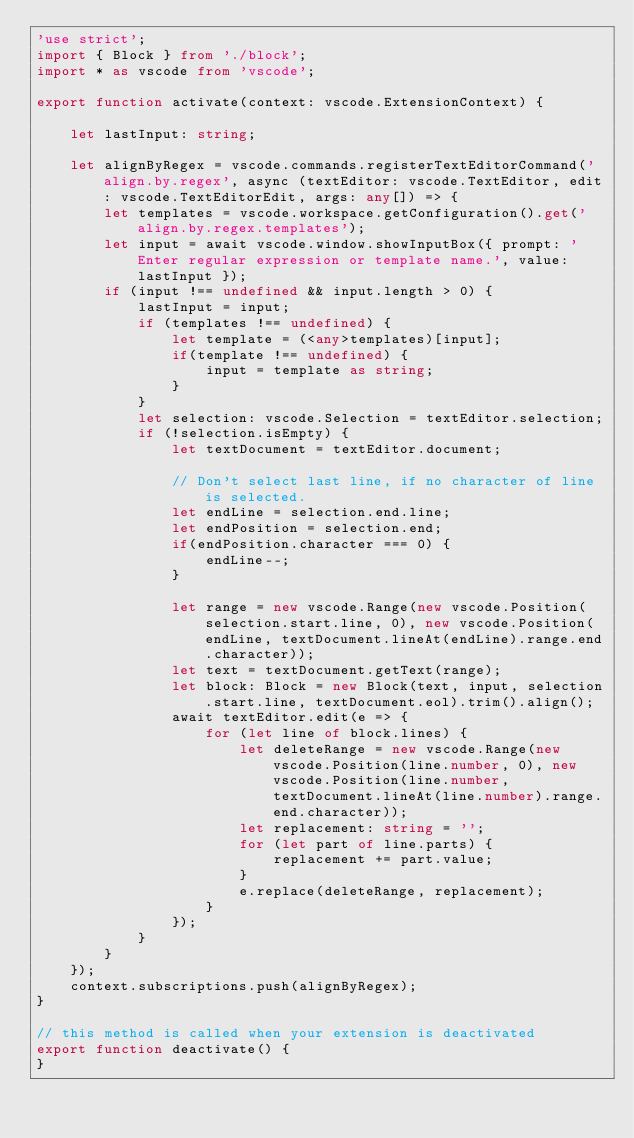<code> <loc_0><loc_0><loc_500><loc_500><_TypeScript_>'use strict';
import { Block } from './block';
import * as vscode from 'vscode';

export function activate(context: vscode.ExtensionContext) {

    let lastInput: string;

    let alignByRegex = vscode.commands.registerTextEditorCommand('align.by.regex', async (textEditor: vscode.TextEditor, edit: vscode.TextEditorEdit, args: any[]) => {
        let templates = vscode.workspace.getConfiguration().get('align.by.regex.templates');
        let input = await vscode.window.showInputBox({ prompt: 'Enter regular expression or template name.', value: lastInput });
        if (input !== undefined && input.length > 0) {
            lastInput = input;
            if (templates !== undefined) {
                let template = (<any>templates)[input];
                if(template !== undefined) {
                    input = template as string;
                }
            }
            let selection: vscode.Selection = textEditor.selection;
            if (!selection.isEmpty) {
                let textDocument = textEditor.document;
                
                // Don't select last line, if no character of line is selected.
                let endLine = selection.end.line;
                let endPosition = selection.end;
                if(endPosition.character === 0) {
                    endLine--;
                }
                
                let range = new vscode.Range(new vscode.Position(selection.start.line, 0), new vscode.Position(endLine, textDocument.lineAt(endLine).range.end.character));
                let text = textDocument.getText(range);
                let block: Block = new Block(text, input, selection.start.line, textDocument.eol).trim().align();
                await textEditor.edit(e => {
                    for (let line of block.lines) {
                        let deleteRange = new vscode.Range(new vscode.Position(line.number, 0), new vscode.Position(line.number, textDocument.lineAt(line.number).range.end.character));
                        let replacement: string = '';
                        for (let part of line.parts) {
                            replacement += part.value;
                        }
                        e.replace(deleteRange, replacement);
                    }
                });
            }
        }
    });
    context.subscriptions.push(alignByRegex);
}

// this method is called when your extension is deactivated
export function deactivate() {
}</code> 